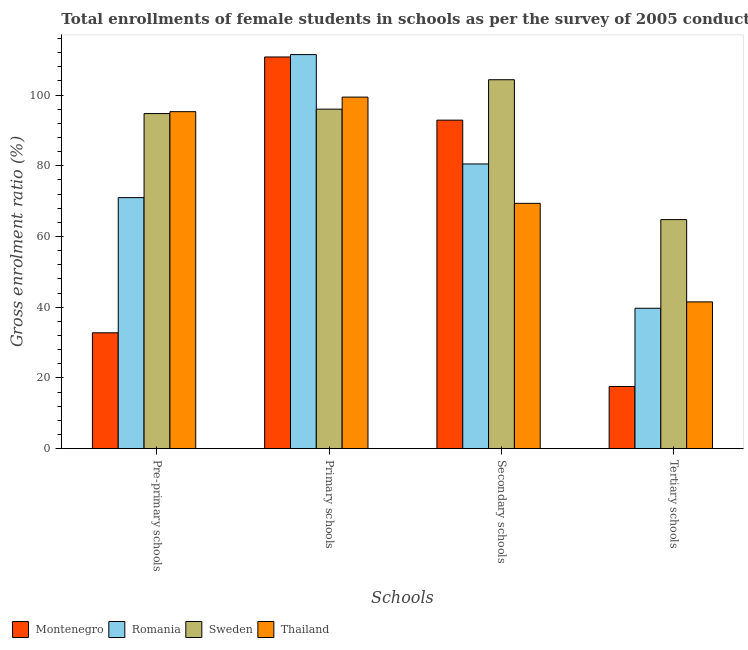How many different coloured bars are there?
Provide a short and direct response. 4. How many groups of bars are there?
Your response must be concise. 4. Are the number of bars on each tick of the X-axis equal?
Offer a very short reply. Yes. How many bars are there on the 2nd tick from the left?
Keep it short and to the point. 4. What is the label of the 3rd group of bars from the left?
Your answer should be very brief. Secondary schools. What is the gross enrolment ratio(female) in secondary schools in Sweden?
Your answer should be very brief. 104.35. Across all countries, what is the maximum gross enrolment ratio(female) in pre-primary schools?
Your response must be concise. 95.32. Across all countries, what is the minimum gross enrolment ratio(female) in tertiary schools?
Provide a short and direct response. 17.58. In which country was the gross enrolment ratio(female) in pre-primary schools maximum?
Keep it short and to the point. Thailand. In which country was the gross enrolment ratio(female) in secondary schools minimum?
Offer a terse response. Thailand. What is the total gross enrolment ratio(female) in secondary schools in the graph?
Provide a succinct answer. 347.18. What is the difference between the gross enrolment ratio(female) in primary schools in Thailand and that in Romania?
Make the answer very short. -12.02. What is the difference between the gross enrolment ratio(female) in secondary schools in Montenegro and the gross enrolment ratio(female) in tertiary schools in Sweden?
Offer a very short reply. 28.13. What is the average gross enrolment ratio(female) in secondary schools per country?
Offer a terse response. 86.8. What is the difference between the gross enrolment ratio(female) in secondary schools and gross enrolment ratio(female) in pre-primary schools in Thailand?
Keep it short and to the point. -25.93. What is the ratio of the gross enrolment ratio(female) in tertiary schools in Sweden to that in Thailand?
Your answer should be compact. 1.56. Is the difference between the gross enrolment ratio(female) in primary schools in Romania and Montenegro greater than the difference between the gross enrolment ratio(female) in secondary schools in Romania and Montenegro?
Offer a terse response. Yes. What is the difference between the highest and the second highest gross enrolment ratio(female) in primary schools?
Keep it short and to the point. 0.68. What is the difference between the highest and the lowest gross enrolment ratio(female) in tertiary schools?
Your answer should be compact. 47.21. In how many countries, is the gross enrolment ratio(female) in secondary schools greater than the average gross enrolment ratio(female) in secondary schools taken over all countries?
Your response must be concise. 2. Is it the case that in every country, the sum of the gross enrolment ratio(female) in secondary schools and gross enrolment ratio(female) in tertiary schools is greater than the sum of gross enrolment ratio(female) in primary schools and gross enrolment ratio(female) in pre-primary schools?
Your response must be concise. No. What does the 4th bar from the left in Tertiary schools represents?
Ensure brevity in your answer.  Thailand. What does the 1st bar from the right in Pre-primary schools represents?
Give a very brief answer. Thailand. How many bars are there?
Give a very brief answer. 16. Are all the bars in the graph horizontal?
Provide a short and direct response. No. How many countries are there in the graph?
Provide a succinct answer. 4. What is the difference between two consecutive major ticks on the Y-axis?
Offer a terse response. 20. Are the values on the major ticks of Y-axis written in scientific E-notation?
Offer a very short reply. No. Does the graph contain any zero values?
Your answer should be very brief. No. Does the graph contain grids?
Your answer should be compact. No. How are the legend labels stacked?
Make the answer very short. Horizontal. What is the title of the graph?
Ensure brevity in your answer.  Total enrollments of female students in schools as per the survey of 2005 conducted in different countries. Does "Ecuador" appear as one of the legend labels in the graph?
Keep it short and to the point. No. What is the label or title of the X-axis?
Provide a succinct answer. Schools. What is the label or title of the Y-axis?
Give a very brief answer. Gross enrolment ratio (%). What is the Gross enrolment ratio (%) in Montenegro in Pre-primary schools?
Your answer should be very brief. 32.78. What is the Gross enrolment ratio (%) in Romania in Pre-primary schools?
Make the answer very short. 71.01. What is the Gross enrolment ratio (%) of Sweden in Pre-primary schools?
Provide a succinct answer. 94.78. What is the Gross enrolment ratio (%) of Thailand in Pre-primary schools?
Offer a terse response. 95.32. What is the Gross enrolment ratio (%) in Montenegro in Primary schools?
Your response must be concise. 110.78. What is the Gross enrolment ratio (%) of Romania in Primary schools?
Your answer should be compact. 111.46. What is the Gross enrolment ratio (%) in Sweden in Primary schools?
Offer a very short reply. 96.03. What is the Gross enrolment ratio (%) in Thailand in Primary schools?
Keep it short and to the point. 99.44. What is the Gross enrolment ratio (%) in Montenegro in Secondary schools?
Offer a terse response. 92.92. What is the Gross enrolment ratio (%) of Romania in Secondary schools?
Make the answer very short. 80.52. What is the Gross enrolment ratio (%) of Sweden in Secondary schools?
Your response must be concise. 104.35. What is the Gross enrolment ratio (%) in Thailand in Secondary schools?
Offer a terse response. 69.39. What is the Gross enrolment ratio (%) of Montenegro in Tertiary schools?
Your answer should be compact. 17.58. What is the Gross enrolment ratio (%) of Romania in Tertiary schools?
Offer a terse response. 39.71. What is the Gross enrolment ratio (%) in Sweden in Tertiary schools?
Keep it short and to the point. 64.79. What is the Gross enrolment ratio (%) in Thailand in Tertiary schools?
Offer a very short reply. 41.52. Across all Schools, what is the maximum Gross enrolment ratio (%) of Montenegro?
Provide a succinct answer. 110.78. Across all Schools, what is the maximum Gross enrolment ratio (%) in Romania?
Provide a short and direct response. 111.46. Across all Schools, what is the maximum Gross enrolment ratio (%) of Sweden?
Offer a terse response. 104.35. Across all Schools, what is the maximum Gross enrolment ratio (%) of Thailand?
Provide a succinct answer. 99.44. Across all Schools, what is the minimum Gross enrolment ratio (%) in Montenegro?
Offer a terse response. 17.58. Across all Schools, what is the minimum Gross enrolment ratio (%) in Romania?
Offer a very short reply. 39.71. Across all Schools, what is the minimum Gross enrolment ratio (%) of Sweden?
Make the answer very short. 64.79. Across all Schools, what is the minimum Gross enrolment ratio (%) in Thailand?
Provide a succinct answer. 41.52. What is the total Gross enrolment ratio (%) of Montenegro in the graph?
Provide a succinct answer. 254.06. What is the total Gross enrolment ratio (%) of Romania in the graph?
Give a very brief answer. 302.71. What is the total Gross enrolment ratio (%) in Sweden in the graph?
Ensure brevity in your answer.  359.95. What is the total Gross enrolment ratio (%) in Thailand in the graph?
Make the answer very short. 305.66. What is the difference between the Gross enrolment ratio (%) of Montenegro in Pre-primary schools and that in Primary schools?
Your response must be concise. -78.01. What is the difference between the Gross enrolment ratio (%) of Romania in Pre-primary schools and that in Primary schools?
Give a very brief answer. -40.45. What is the difference between the Gross enrolment ratio (%) in Sweden in Pre-primary schools and that in Primary schools?
Offer a very short reply. -1.24. What is the difference between the Gross enrolment ratio (%) of Thailand in Pre-primary schools and that in Primary schools?
Provide a succinct answer. -4.12. What is the difference between the Gross enrolment ratio (%) in Montenegro in Pre-primary schools and that in Secondary schools?
Provide a short and direct response. -60.14. What is the difference between the Gross enrolment ratio (%) in Romania in Pre-primary schools and that in Secondary schools?
Your answer should be compact. -9.51. What is the difference between the Gross enrolment ratio (%) in Sweden in Pre-primary schools and that in Secondary schools?
Keep it short and to the point. -9.57. What is the difference between the Gross enrolment ratio (%) in Thailand in Pre-primary schools and that in Secondary schools?
Your answer should be compact. 25.93. What is the difference between the Gross enrolment ratio (%) of Montenegro in Pre-primary schools and that in Tertiary schools?
Ensure brevity in your answer.  15.2. What is the difference between the Gross enrolment ratio (%) of Romania in Pre-primary schools and that in Tertiary schools?
Your answer should be compact. 31.3. What is the difference between the Gross enrolment ratio (%) in Sweden in Pre-primary schools and that in Tertiary schools?
Your answer should be compact. 29.99. What is the difference between the Gross enrolment ratio (%) in Thailand in Pre-primary schools and that in Tertiary schools?
Provide a succinct answer. 53.8. What is the difference between the Gross enrolment ratio (%) in Montenegro in Primary schools and that in Secondary schools?
Offer a terse response. 17.87. What is the difference between the Gross enrolment ratio (%) of Romania in Primary schools and that in Secondary schools?
Offer a very short reply. 30.94. What is the difference between the Gross enrolment ratio (%) of Sweden in Primary schools and that in Secondary schools?
Offer a very short reply. -8.33. What is the difference between the Gross enrolment ratio (%) in Thailand in Primary schools and that in Secondary schools?
Offer a very short reply. 30.05. What is the difference between the Gross enrolment ratio (%) of Montenegro in Primary schools and that in Tertiary schools?
Offer a very short reply. 93.2. What is the difference between the Gross enrolment ratio (%) in Romania in Primary schools and that in Tertiary schools?
Your response must be concise. 71.75. What is the difference between the Gross enrolment ratio (%) of Sweden in Primary schools and that in Tertiary schools?
Make the answer very short. 31.24. What is the difference between the Gross enrolment ratio (%) in Thailand in Primary schools and that in Tertiary schools?
Give a very brief answer. 57.92. What is the difference between the Gross enrolment ratio (%) in Montenegro in Secondary schools and that in Tertiary schools?
Give a very brief answer. 75.33. What is the difference between the Gross enrolment ratio (%) in Romania in Secondary schools and that in Tertiary schools?
Your answer should be very brief. 40.81. What is the difference between the Gross enrolment ratio (%) of Sweden in Secondary schools and that in Tertiary schools?
Offer a terse response. 39.56. What is the difference between the Gross enrolment ratio (%) of Thailand in Secondary schools and that in Tertiary schools?
Keep it short and to the point. 27.87. What is the difference between the Gross enrolment ratio (%) of Montenegro in Pre-primary schools and the Gross enrolment ratio (%) of Romania in Primary schools?
Your answer should be compact. -78.69. What is the difference between the Gross enrolment ratio (%) in Montenegro in Pre-primary schools and the Gross enrolment ratio (%) in Sweden in Primary schools?
Give a very brief answer. -63.25. What is the difference between the Gross enrolment ratio (%) of Montenegro in Pre-primary schools and the Gross enrolment ratio (%) of Thailand in Primary schools?
Make the answer very short. -66.66. What is the difference between the Gross enrolment ratio (%) of Romania in Pre-primary schools and the Gross enrolment ratio (%) of Sweden in Primary schools?
Offer a very short reply. -25.02. What is the difference between the Gross enrolment ratio (%) in Romania in Pre-primary schools and the Gross enrolment ratio (%) in Thailand in Primary schools?
Your answer should be very brief. -28.43. What is the difference between the Gross enrolment ratio (%) of Sweden in Pre-primary schools and the Gross enrolment ratio (%) of Thailand in Primary schools?
Ensure brevity in your answer.  -4.66. What is the difference between the Gross enrolment ratio (%) of Montenegro in Pre-primary schools and the Gross enrolment ratio (%) of Romania in Secondary schools?
Provide a succinct answer. -47.75. What is the difference between the Gross enrolment ratio (%) of Montenegro in Pre-primary schools and the Gross enrolment ratio (%) of Sweden in Secondary schools?
Your answer should be compact. -71.57. What is the difference between the Gross enrolment ratio (%) in Montenegro in Pre-primary schools and the Gross enrolment ratio (%) in Thailand in Secondary schools?
Keep it short and to the point. -36.61. What is the difference between the Gross enrolment ratio (%) of Romania in Pre-primary schools and the Gross enrolment ratio (%) of Sweden in Secondary schools?
Keep it short and to the point. -33.34. What is the difference between the Gross enrolment ratio (%) of Romania in Pre-primary schools and the Gross enrolment ratio (%) of Thailand in Secondary schools?
Offer a very short reply. 1.62. What is the difference between the Gross enrolment ratio (%) of Sweden in Pre-primary schools and the Gross enrolment ratio (%) of Thailand in Secondary schools?
Offer a very short reply. 25.39. What is the difference between the Gross enrolment ratio (%) of Montenegro in Pre-primary schools and the Gross enrolment ratio (%) of Romania in Tertiary schools?
Your answer should be very brief. -6.94. What is the difference between the Gross enrolment ratio (%) in Montenegro in Pre-primary schools and the Gross enrolment ratio (%) in Sweden in Tertiary schools?
Your answer should be very brief. -32.01. What is the difference between the Gross enrolment ratio (%) in Montenegro in Pre-primary schools and the Gross enrolment ratio (%) in Thailand in Tertiary schools?
Make the answer very short. -8.74. What is the difference between the Gross enrolment ratio (%) in Romania in Pre-primary schools and the Gross enrolment ratio (%) in Sweden in Tertiary schools?
Make the answer very short. 6.22. What is the difference between the Gross enrolment ratio (%) in Romania in Pre-primary schools and the Gross enrolment ratio (%) in Thailand in Tertiary schools?
Make the answer very short. 29.49. What is the difference between the Gross enrolment ratio (%) of Sweden in Pre-primary schools and the Gross enrolment ratio (%) of Thailand in Tertiary schools?
Provide a short and direct response. 53.27. What is the difference between the Gross enrolment ratio (%) of Montenegro in Primary schools and the Gross enrolment ratio (%) of Romania in Secondary schools?
Provide a short and direct response. 30.26. What is the difference between the Gross enrolment ratio (%) of Montenegro in Primary schools and the Gross enrolment ratio (%) of Sweden in Secondary schools?
Provide a short and direct response. 6.43. What is the difference between the Gross enrolment ratio (%) in Montenegro in Primary schools and the Gross enrolment ratio (%) in Thailand in Secondary schools?
Offer a terse response. 41.39. What is the difference between the Gross enrolment ratio (%) of Romania in Primary schools and the Gross enrolment ratio (%) of Sweden in Secondary schools?
Offer a very short reply. 7.11. What is the difference between the Gross enrolment ratio (%) in Romania in Primary schools and the Gross enrolment ratio (%) in Thailand in Secondary schools?
Ensure brevity in your answer.  42.07. What is the difference between the Gross enrolment ratio (%) of Sweden in Primary schools and the Gross enrolment ratio (%) of Thailand in Secondary schools?
Provide a short and direct response. 26.64. What is the difference between the Gross enrolment ratio (%) in Montenegro in Primary schools and the Gross enrolment ratio (%) in Romania in Tertiary schools?
Your answer should be compact. 71.07. What is the difference between the Gross enrolment ratio (%) in Montenegro in Primary schools and the Gross enrolment ratio (%) in Sweden in Tertiary schools?
Give a very brief answer. 45.99. What is the difference between the Gross enrolment ratio (%) in Montenegro in Primary schools and the Gross enrolment ratio (%) in Thailand in Tertiary schools?
Your response must be concise. 69.27. What is the difference between the Gross enrolment ratio (%) in Romania in Primary schools and the Gross enrolment ratio (%) in Sweden in Tertiary schools?
Offer a terse response. 46.67. What is the difference between the Gross enrolment ratio (%) in Romania in Primary schools and the Gross enrolment ratio (%) in Thailand in Tertiary schools?
Your answer should be compact. 69.95. What is the difference between the Gross enrolment ratio (%) of Sweden in Primary schools and the Gross enrolment ratio (%) of Thailand in Tertiary schools?
Keep it short and to the point. 54.51. What is the difference between the Gross enrolment ratio (%) in Montenegro in Secondary schools and the Gross enrolment ratio (%) in Romania in Tertiary schools?
Provide a short and direct response. 53.2. What is the difference between the Gross enrolment ratio (%) in Montenegro in Secondary schools and the Gross enrolment ratio (%) in Sweden in Tertiary schools?
Provide a short and direct response. 28.13. What is the difference between the Gross enrolment ratio (%) in Montenegro in Secondary schools and the Gross enrolment ratio (%) in Thailand in Tertiary schools?
Make the answer very short. 51.4. What is the difference between the Gross enrolment ratio (%) in Romania in Secondary schools and the Gross enrolment ratio (%) in Sweden in Tertiary schools?
Ensure brevity in your answer.  15.73. What is the difference between the Gross enrolment ratio (%) of Romania in Secondary schools and the Gross enrolment ratio (%) of Thailand in Tertiary schools?
Your response must be concise. 39.01. What is the difference between the Gross enrolment ratio (%) of Sweden in Secondary schools and the Gross enrolment ratio (%) of Thailand in Tertiary schools?
Offer a very short reply. 62.83. What is the average Gross enrolment ratio (%) of Montenegro per Schools?
Provide a short and direct response. 63.51. What is the average Gross enrolment ratio (%) in Romania per Schools?
Keep it short and to the point. 75.68. What is the average Gross enrolment ratio (%) in Sweden per Schools?
Offer a very short reply. 89.99. What is the average Gross enrolment ratio (%) of Thailand per Schools?
Your response must be concise. 76.42. What is the difference between the Gross enrolment ratio (%) of Montenegro and Gross enrolment ratio (%) of Romania in Pre-primary schools?
Your answer should be very brief. -38.23. What is the difference between the Gross enrolment ratio (%) of Montenegro and Gross enrolment ratio (%) of Sweden in Pre-primary schools?
Your answer should be very brief. -62.01. What is the difference between the Gross enrolment ratio (%) in Montenegro and Gross enrolment ratio (%) in Thailand in Pre-primary schools?
Offer a terse response. -62.54. What is the difference between the Gross enrolment ratio (%) in Romania and Gross enrolment ratio (%) in Sweden in Pre-primary schools?
Your answer should be compact. -23.77. What is the difference between the Gross enrolment ratio (%) in Romania and Gross enrolment ratio (%) in Thailand in Pre-primary schools?
Ensure brevity in your answer.  -24.31. What is the difference between the Gross enrolment ratio (%) in Sweden and Gross enrolment ratio (%) in Thailand in Pre-primary schools?
Give a very brief answer. -0.54. What is the difference between the Gross enrolment ratio (%) of Montenegro and Gross enrolment ratio (%) of Romania in Primary schools?
Your response must be concise. -0.68. What is the difference between the Gross enrolment ratio (%) of Montenegro and Gross enrolment ratio (%) of Sweden in Primary schools?
Provide a short and direct response. 14.76. What is the difference between the Gross enrolment ratio (%) of Montenegro and Gross enrolment ratio (%) of Thailand in Primary schools?
Your answer should be compact. 11.35. What is the difference between the Gross enrolment ratio (%) of Romania and Gross enrolment ratio (%) of Sweden in Primary schools?
Your response must be concise. 15.44. What is the difference between the Gross enrolment ratio (%) of Romania and Gross enrolment ratio (%) of Thailand in Primary schools?
Offer a very short reply. 12.02. What is the difference between the Gross enrolment ratio (%) of Sweden and Gross enrolment ratio (%) of Thailand in Primary schools?
Offer a terse response. -3.41. What is the difference between the Gross enrolment ratio (%) of Montenegro and Gross enrolment ratio (%) of Romania in Secondary schools?
Ensure brevity in your answer.  12.39. What is the difference between the Gross enrolment ratio (%) of Montenegro and Gross enrolment ratio (%) of Sweden in Secondary schools?
Keep it short and to the point. -11.44. What is the difference between the Gross enrolment ratio (%) of Montenegro and Gross enrolment ratio (%) of Thailand in Secondary schools?
Your answer should be very brief. 23.53. What is the difference between the Gross enrolment ratio (%) of Romania and Gross enrolment ratio (%) of Sweden in Secondary schools?
Your response must be concise. -23.83. What is the difference between the Gross enrolment ratio (%) of Romania and Gross enrolment ratio (%) of Thailand in Secondary schools?
Your answer should be compact. 11.13. What is the difference between the Gross enrolment ratio (%) of Sweden and Gross enrolment ratio (%) of Thailand in Secondary schools?
Ensure brevity in your answer.  34.96. What is the difference between the Gross enrolment ratio (%) in Montenegro and Gross enrolment ratio (%) in Romania in Tertiary schools?
Provide a short and direct response. -22.13. What is the difference between the Gross enrolment ratio (%) of Montenegro and Gross enrolment ratio (%) of Sweden in Tertiary schools?
Offer a very short reply. -47.21. What is the difference between the Gross enrolment ratio (%) in Montenegro and Gross enrolment ratio (%) in Thailand in Tertiary schools?
Give a very brief answer. -23.93. What is the difference between the Gross enrolment ratio (%) in Romania and Gross enrolment ratio (%) in Sweden in Tertiary schools?
Offer a very short reply. -25.08. What is the difference between the Gross enrolment ratio (%) of Romania and Gross enrolment ratio (%) of Thailand in Tertiary schools?
Ensure brevity in your answer.  -1.8. What is the difference between the Gross enrolment ratio (%) in Sweden and Gross enrolment ratio (%) in Thailand in Tertiary schools?
Ensure brevity in your answer.  23.27. What is the ratio of the Gross enrolment ratio (%) of Montenegro in Pre-primary schools to that in Primary schools?
Provide a succinct answer. 0.3. What is the ratio of the Gross enrolment ratio (%) in Romania in Pre-primary schools to that in Primary schools?
Offer a very short reply. 0.64. What is the ratio of the Gross enrolment ratio (%) of Sweden in Pre-primary schools to that in Primary schools?
Offer a very short reply. 0.99. What is the ratio of the Gross enrolment ratio (%) in Thailand in Pre-primary schools to that in Primary schools?
Ensure brevity in your answer.  0.96. What is the ratio of the Gross enrolment ratio (%) in Montenegro in Pre-primary schools to that in Secondary schools?
Ensure brevity in your answer.  0.35. What is the ratio of the Gross enrolment ratio (%) of Romania in Pre-primary schools to that in Secondary schools?
Make the answer very short. 0.88. What is the ratio of the Gross enrolment ratio (%) in Sweden in Pre-primary schools to that in Secondary schools?
Provide a succinct answer. 0.91. What is the ratio of the Gross enrolment ratio (%) in Thailand in Pre-primary schools to that in Secondary schools?
Offer a terse response. 1.37. What is the ratio of the Gross enrolment ratio (%) in Montenegro in Pre-primary schools to that in Tertiary schools?
Ensure brevity in your answer.  1.86. What is the ratio of the Gross enrolment ratio (%) of Romania in Pre-primary schools to that in Tertiary schools?
Give a very brief answer. 1.79. What is the ratio of the Gross enrolment ratio (%) in Sweden in Pre-primary schools to that in Tertiary schools?
Provide a short and direct response. 1.46. What is the ratio of the Gross enrolment ratio (%) of Thailand in Pre-primary schools to that in Tertiary schools?
Give a very brief answer. 2.3. What is the ratio of the Gross enrolment ratio (%) of Montenegro in Primary schools to that in Secondary schools?
Provide a short and direct response. 1.19. What is the ratio of the Gross enrolment ratio (%) in Romania in Primary schools to that in Secondary schools?
Your answer should be compact. 1.38. What is the ratio of the Gross enrolment ratio (%) in Sweden in Primary schools to that in Secondary schools?
Offer a terse response. 0.92. What is the ratio of the Gross enrolment ratio (%) in Thailand in Primary schools to that in Secondary schools?
Offer a terse response. 1.43. What is the ratio of the Gross enrolment ratio (%) in Montenegro in Primary schools to that in Tertiary schools?
Provide a succinct answer. 6.3. What is the ratio of the Gross enrolment ratio (%) of Romania in Primary schools to that in Tertiary schools?
Provide a succinct answer. 2.81. What is the ratio of the Gross enrolment ratio (%) of Sweden in Primary schools to that in Tertiary schools?
Offer a terse response. 1.48. What is the ratio of the Gross enrolment ratio (%) of Thailand in Primary schools to that in Tertiary schools?
Provide a short and direct response. 2.4. What is the ratio of the Gross enrolment ratio (%) of Montenegro in Secondary schools to that in Tertiary schools?
Your response must be concise. 5.28. What is the ratio of the Gross enrolment ratio (%) of Romania in Secondary schools to that in Tertiary schools?
Provide a succinct answer. 2.03. What is the ratio of the Gross enrolment ratio (%) of Sweden in Secondary schools to that in Tertiary schools?
Make the answer very short. 1.61. What is the ratio of the Gross enrolment ratio (%) in Thailand in Secondary schools to that in Tertiary schools?
Offer a terse response. 1.67. What is the difference between the highest and the second highest Gross enrolment ratio (%) of Montenegro?
Your response must be concise. 17.87. What is the difference between the highest and the second highest Gross enrolment ratio (%) in Romania?
Make the answer very short. 30.94. What is the difference between the highest and the second highest Gross enrolment ratio (%) in Sweden?
Make the answer very short. 8.33. What is the difference between the highest and the second highest Gross enrolment ratio (%) in Thailand?
Provide a short and direct response. 4.12. What is the difference between the highest and the lowest Gross enrolment ratio (%) in Montenegro?
Your answer should be compact. 93.2. What is the difference between the highest and the lowest Gross enrolment ratio (%) of Romania?
Provide a succinct answer. 71.75. What is the difference between the highest and the lowest Gross enrolment ratio (%) of Sweden?
Your answer should be very brief. 39.56. What is the difference between the highest and the lowest Gross enrolment ratio (%) in Thailand?
Your answer should be compact. 57.92. 